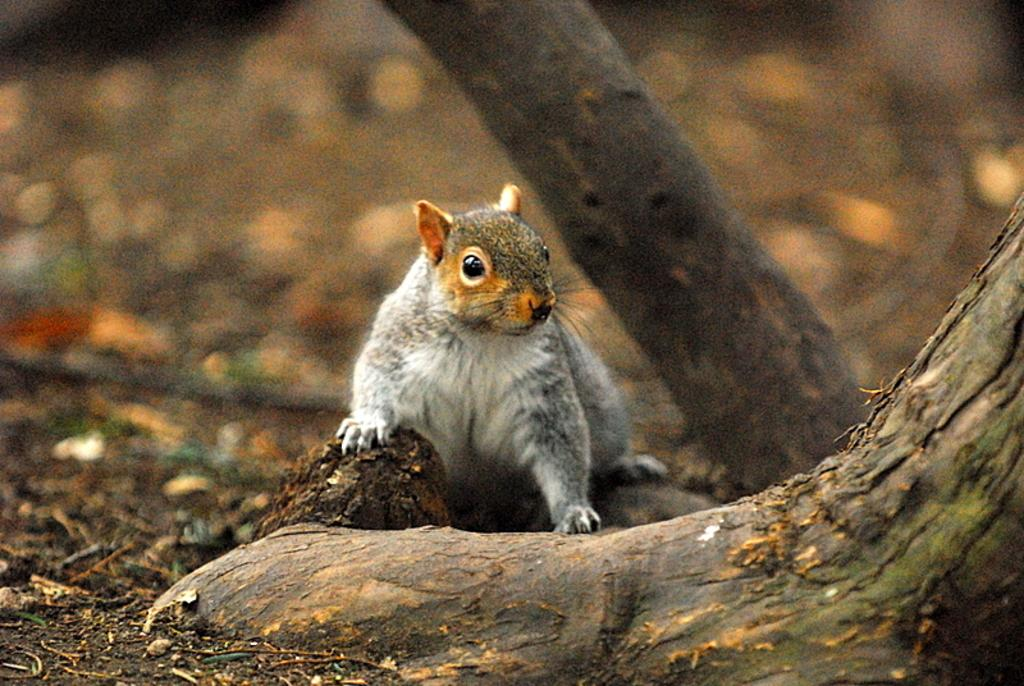What type of animal is in the image? The specific type of animal cannot be determined from the provided facts. What can be said about the background of the image? The background of the image is blurred. How many girls are riding the train in the image? There is no train or girls present in the image; it features an animal with a blurred background. 